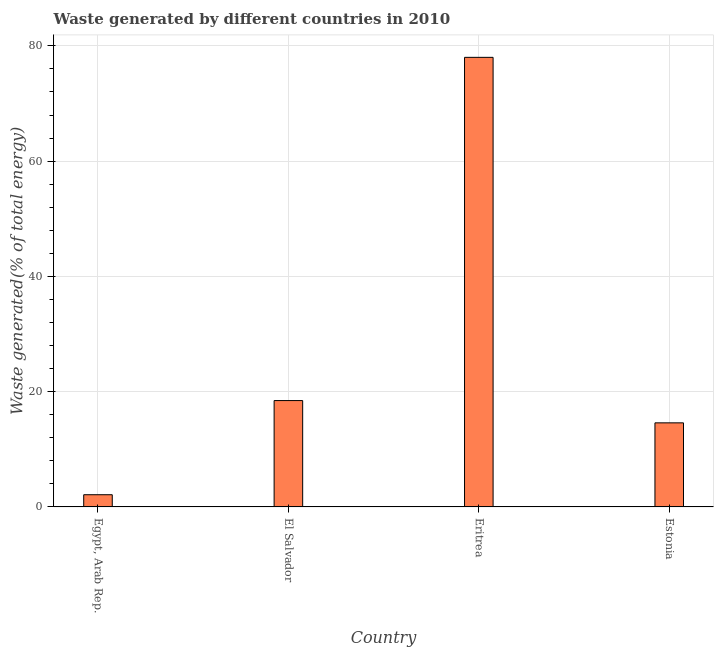Does the graph contain any zero values?
Make the answer very short. No. What is the title of the graph?
Your answer should be very brief. Waste generated by different countries in 2010. What is the label or title of the Y-axis?
Provide a succinct answer. Waste generated(% of total energy). What is the amount of waste generated in El Salvador?
Give a very brief answer. 18.45. Across all countries, what is the maximum amount of waste generated?
Your answer should be very brief. 78.01. Across all countries, what is the minimum amount of waste generated?
Offer a terse response. 2.12. In which country was the amount of waste generated maximum?
Make the answer very short. Eritrea. In which country was the amount of waste generated minimum?
Offer a terse response. Egypt, Arab Rep. What is the sum of the amount of waste generated?
Your response must be concise. 113.17. What is the difference between the amount of waste generated in El Salvador and Eritrea?
Keep it short and to the point. -59.55. What is the average amount of waste generated per country?
Provide a succinct answer. 28.29. What is the median amount of waste generated?
Provide a succinct answer. 16.52. What is the ratio of the amount of waste generated in El Salvador to that in Estonia?
Provide a short and direct response. 1.26. Is the difference between the amount of waste generated in Egypt, Arab Rep. and El Salvador greater than the difference between any two countries?
Offer a very short reply. No. What is the difference between the highest and the second highest amount of waste generated?
Ensure brevity in your answer.  59.55. Is the sum of the amount of waste generated in El Salvador and Eritrea greater than the maximum amount of waste generated across all countries?
Your answer should be very brief. Yes. What is the difference between the highest and the lowest amount of waste generated?
Give a very brief answer. 75.89. In how many countries, is the amount of waste generated greater than the average amount of waste generated taken over all countries?
Make the answer very short. 1. How many bars are there?
Offer a terse response. 4. Are all the bars in the graph horizontal?
Ensure brevity in your answer.  No. How many countries are there in the graph?
Your answer should be very brief. 4. What is the Waste generated(% of total energy) of Egypt, Arab Rep.?
Keep it short and to the point. 2.12. What is the Waste generated(% of total energy) in El Salvador?
Give a very brief answer. 18.45. What is the Waste generated(% of total energy) in Eritrea?
Your answer should be very brief. 78.01. What is the Waste generated(% of total energy) of Estonia?
Provide a succinct answer. 14.59. What is the difference between the Waste generated(% of total energy) in Egypt, Arab Rep. and El Salvador?
Provide a short and direct response. -16.34. What is the difference between the Waste generated(% of total energy) in Egypt, Arab Rep. and Eritrea?
Make the answer very short. -75.89. What is the difference between the Waste generated(% of total energy) in Egypt, Arab Rep. and Estonia?
Make the answer very short. -12.47. What is the difference between the Waste generated(% of total energy) in El Salvador and Eritrea?
Ensure brevity in your answer.  -59.55. What is the difference between the Waste generated(% of total energy) in El Salvador and Estonia?
Keep it short and to the point. 3.87. What is the difference between the Waste generated(% of total energy) in Eritrea and Estonia?
Your answer should be very brief. 63.42. What is the ratio of the Waste generated(% of total energy) in Egypt, Arab Rep. to that in El Salvador?
Provide a short and direct response. 0.12. What is the ratio of the Waste generated(% of total energy) in Egypt, Arab Rep. to that in Eritrea?
Provide a short and direct response. 0.03. What is the ratio of the Waste generated(% of total energy) in Egypt, Arab Rep. to that in Estonia?
Your answer should be very brief. 0.14. What is the ratio of the Waste generated(% of total energy) in El Salvador to that in Eritrea?
Offer a terse response. 0.24. What is the ratio of the Waste generated(% of total energy) in El Salvador to that in Estonia?
Your answer should be very brief. 1.26. What is the ratio of the Waste generated(% of total energy) in Eritrea to that in Estonia?
Offer a very short reply. 5.35. 